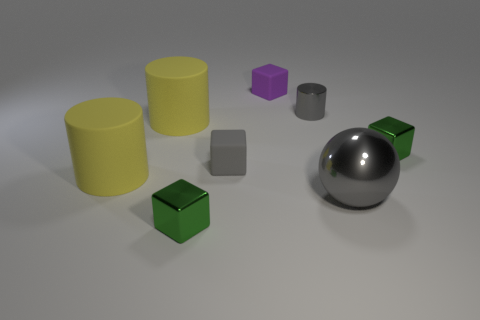Does the cylinder right of the small purple block have the same size as the ball that is on the right side of the tiny purple rubber cube?
Make the answer very short. No. Do the gray ball and the green block behind the large gray metal ball have the same size?
Your answer should be very brief. No. There is a yellow cylinder in front of the gray matte cube; are there any matte cubes that are left of it?
Offer a very short reply. No. There is a small green shiny object on the left side of the tiny purple rubber cube; what is its shape?
Give a very brief answer. Cube. What is the material of the tiny cylinder that is the same color as the big sphere?
Provide a short and direct response. Metal. What color is the tiny cylinder to the left of the green object that is right of the gray sphere?
Your response must be concise. Gray. Does the gray shiny sphere have the same size as the purple matte cube?
Make the answer very short. No. There is a gray thing that is the same shape as the small purple object; what is it made of?
Provide a succinct answer. Rubber. How many purple things are the same size as the gray matte object?
Keep it short and to the point. 1. The tiny block that is the same material as the purple thing is what color?
Offer a terse response. Gray. 